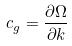Convert formula to latex. <formula><loc_0><loc_0><loc_500><loc_500>c _ { g } = \frac { \partial \Omega } { \partial k }</formula> 